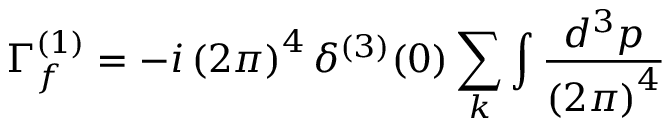<formula> <loc_0><loc_0><loc_500><loc_500>\Gamma _ { f } ^ { ( 1 ) } = - i \left ( 2 \pi \right ) ^ { 4 } \delta ^ { ( 3 ) } ( 0 ) \sum _ { k } \int \frac { d ^ { 3 } p } { \left ( 2 \pi \right ) ^ { 4 } }</formula> 